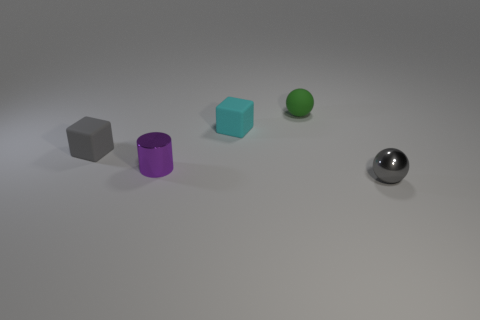Add 2 metal cylinders. How many objects exist? 7 Subtract all cubes. How many objects are left? 3 Subtract 0 blue cylinders. How many objects are left? 5 Subtract all cyan matte cylinders. Subtract all gray things. How many objects are left? 3 Add 2 gray matte things. How many gray matte things are left? 3 Add 3 matte cylinders. How many matte cylinders exist? 3 